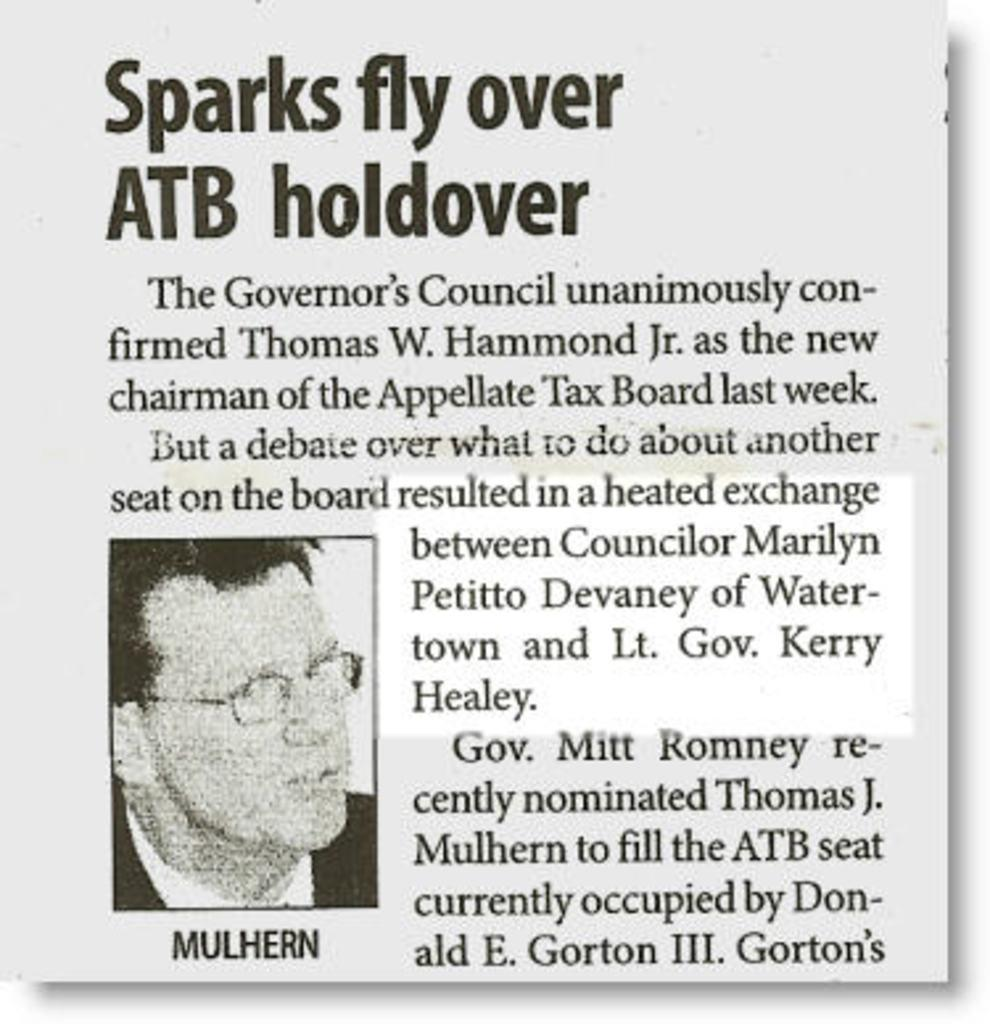What is present in the image that contains both text and an image? There is a poster in the image that contains text and an image. Can you describe the content of the poster? The poster contains text and an image, but the specific content cannot be determined from the provided facts. How does the poster contribute to reducing pollution in the image? There is no information about pollution or any environmental concerns in the image, so it is not possible to determine how the poster might contribute to reducing pollution. 